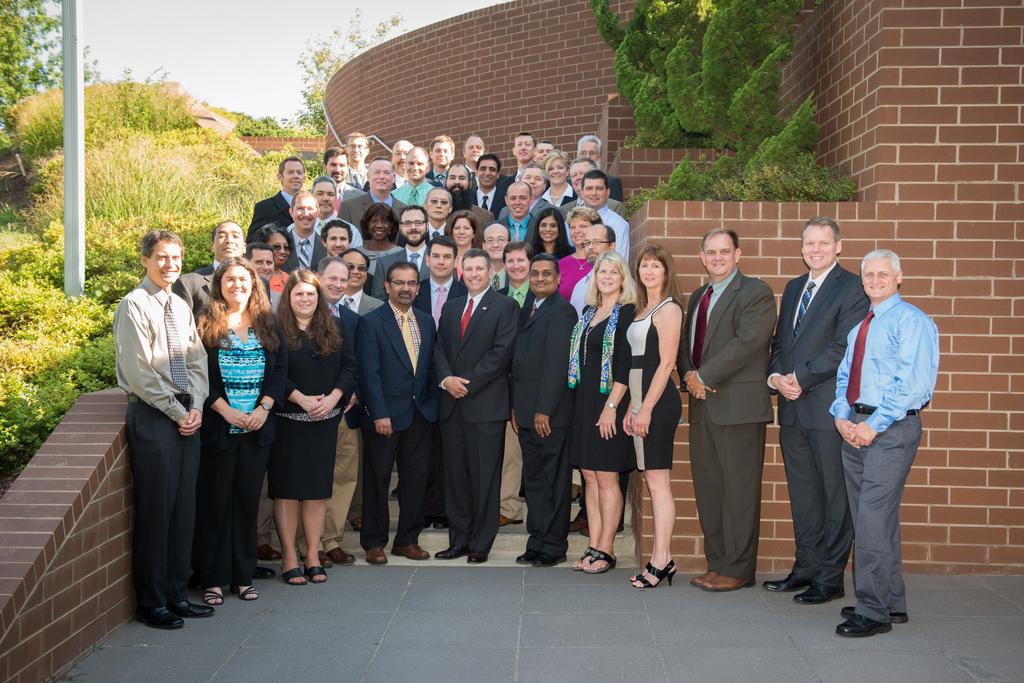What types of people are in the image? There are men and women in the image. What are the people in the image doing? The people are standing and smiling. What can be seen in the background of the image? There is a brick wall, trees, and the sky visible in the background of the image. Can you tell me how many bees are buzzing around the people in the image? There are no bees present in the image; it only features men, women, a brick wall, trees, and the sky. What type of business is being conducted in the image? There is no indication of any business being conducted in the image; it simply shows people standing and smiling. 